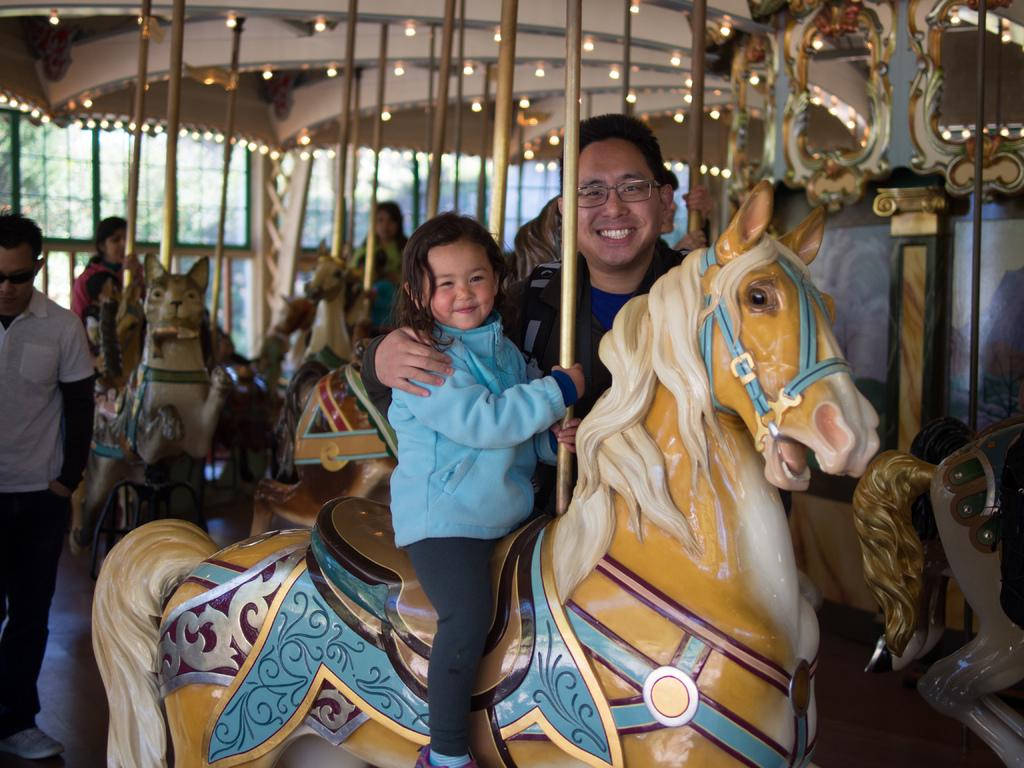Who is present in the image? There is a man and two girls in the image. What are the girls doing in the image? One girl is sitting on a horse, and another girl is sitting on another horse. What can be seen in the background of the image? There is light visible in the background of the image. What is the person in the image doing? There is a person walking in the image. What type of sponge is being used by the girl sitting on the horse? There is no sponge present in the image, and the girl sitting on the horse is not using any sponge. How many books can be seen in the image? There are no books visible in the image. 